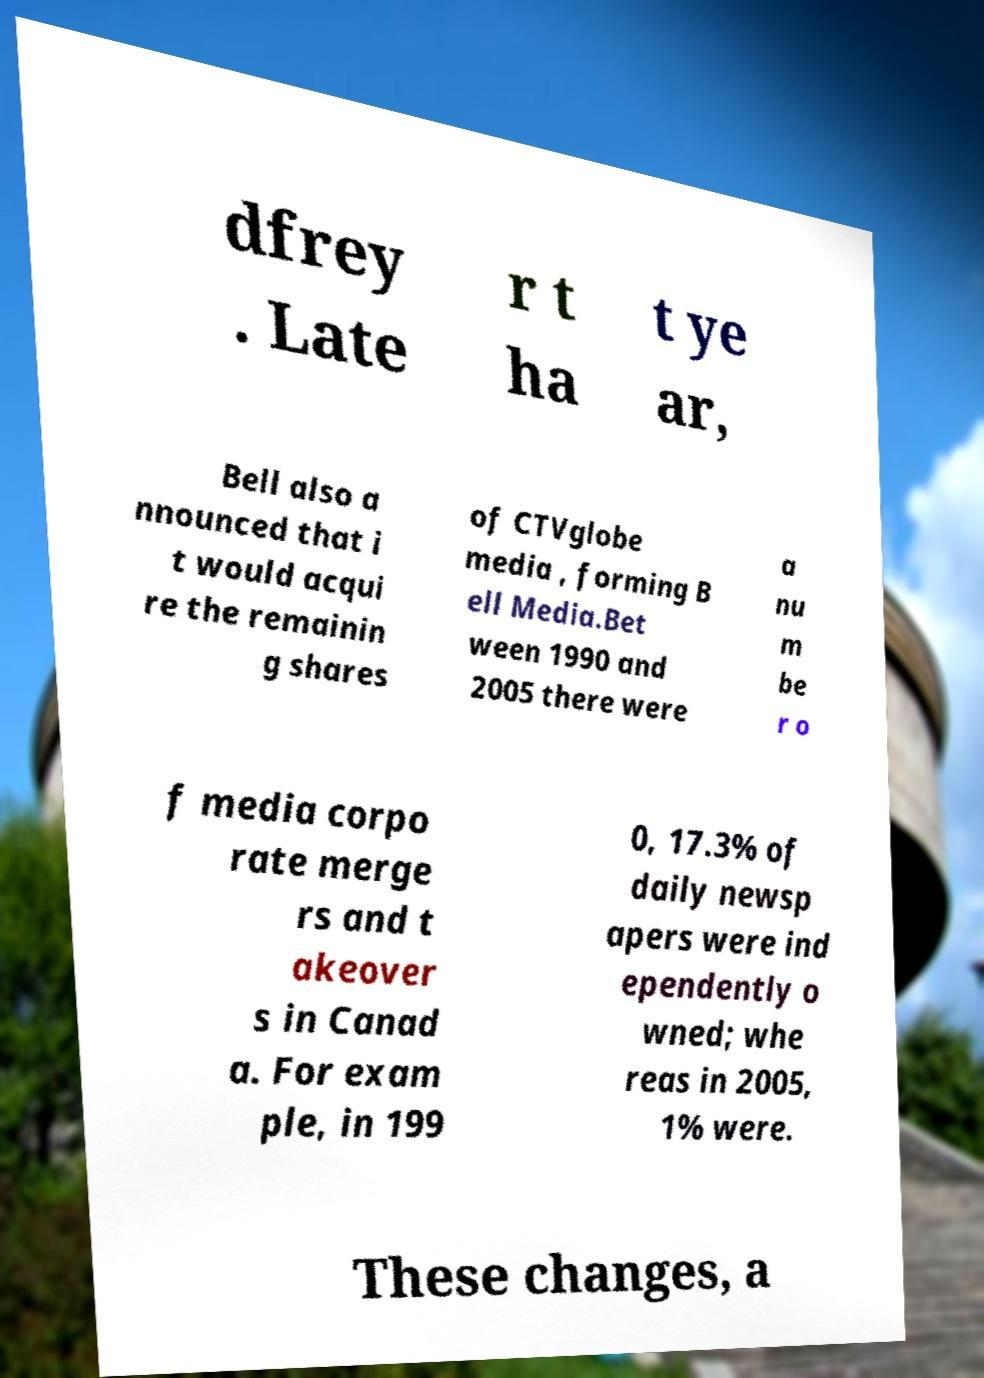Can you read and provide the text displayed in the image?This photo seems to have some interesting text. Can you extract and type it out for me? dfrey . Late r t ha t ye ar, Bell also a nnounced that i t would acqui re the remainin g shares of CTVglobe media , forming B ell Media.Bet ween 1990 and 2005 there were a nu m be r o f media corpo rate merge rs and t akeover s in Canad a. For exam ple, in 199 0, 17.3% of daily newsp apers were ind ependently o wned; whe reas in 2005, 1% were. These changes, a 